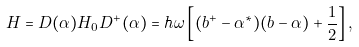Convert formula to latex. <formula><loc_0><loc_0><loc_500><loc_500>H = D ( \alpha ) H _ { 0 } D ^ { + } ( \alpha ) = \hbar { \omega } \left [ ( b ^ { + } - \alpha ^ { * } ) ( b - \alpha ) + \frac { 1 } { 2 } \right ] ,</formula> 